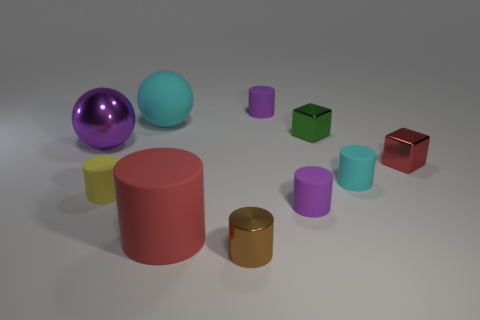If I had to pick one of these objects to best represent durability, which one should I choose based on their appearance? Judging by their appearance, the red cube at the forefront might represent durability well. It has a reflective, metallic sheen, and its geometric shape with sharp, defined edges conveys a sense of sturdiness and solidity, which are often associated with materials able to withstand wear and stress. 